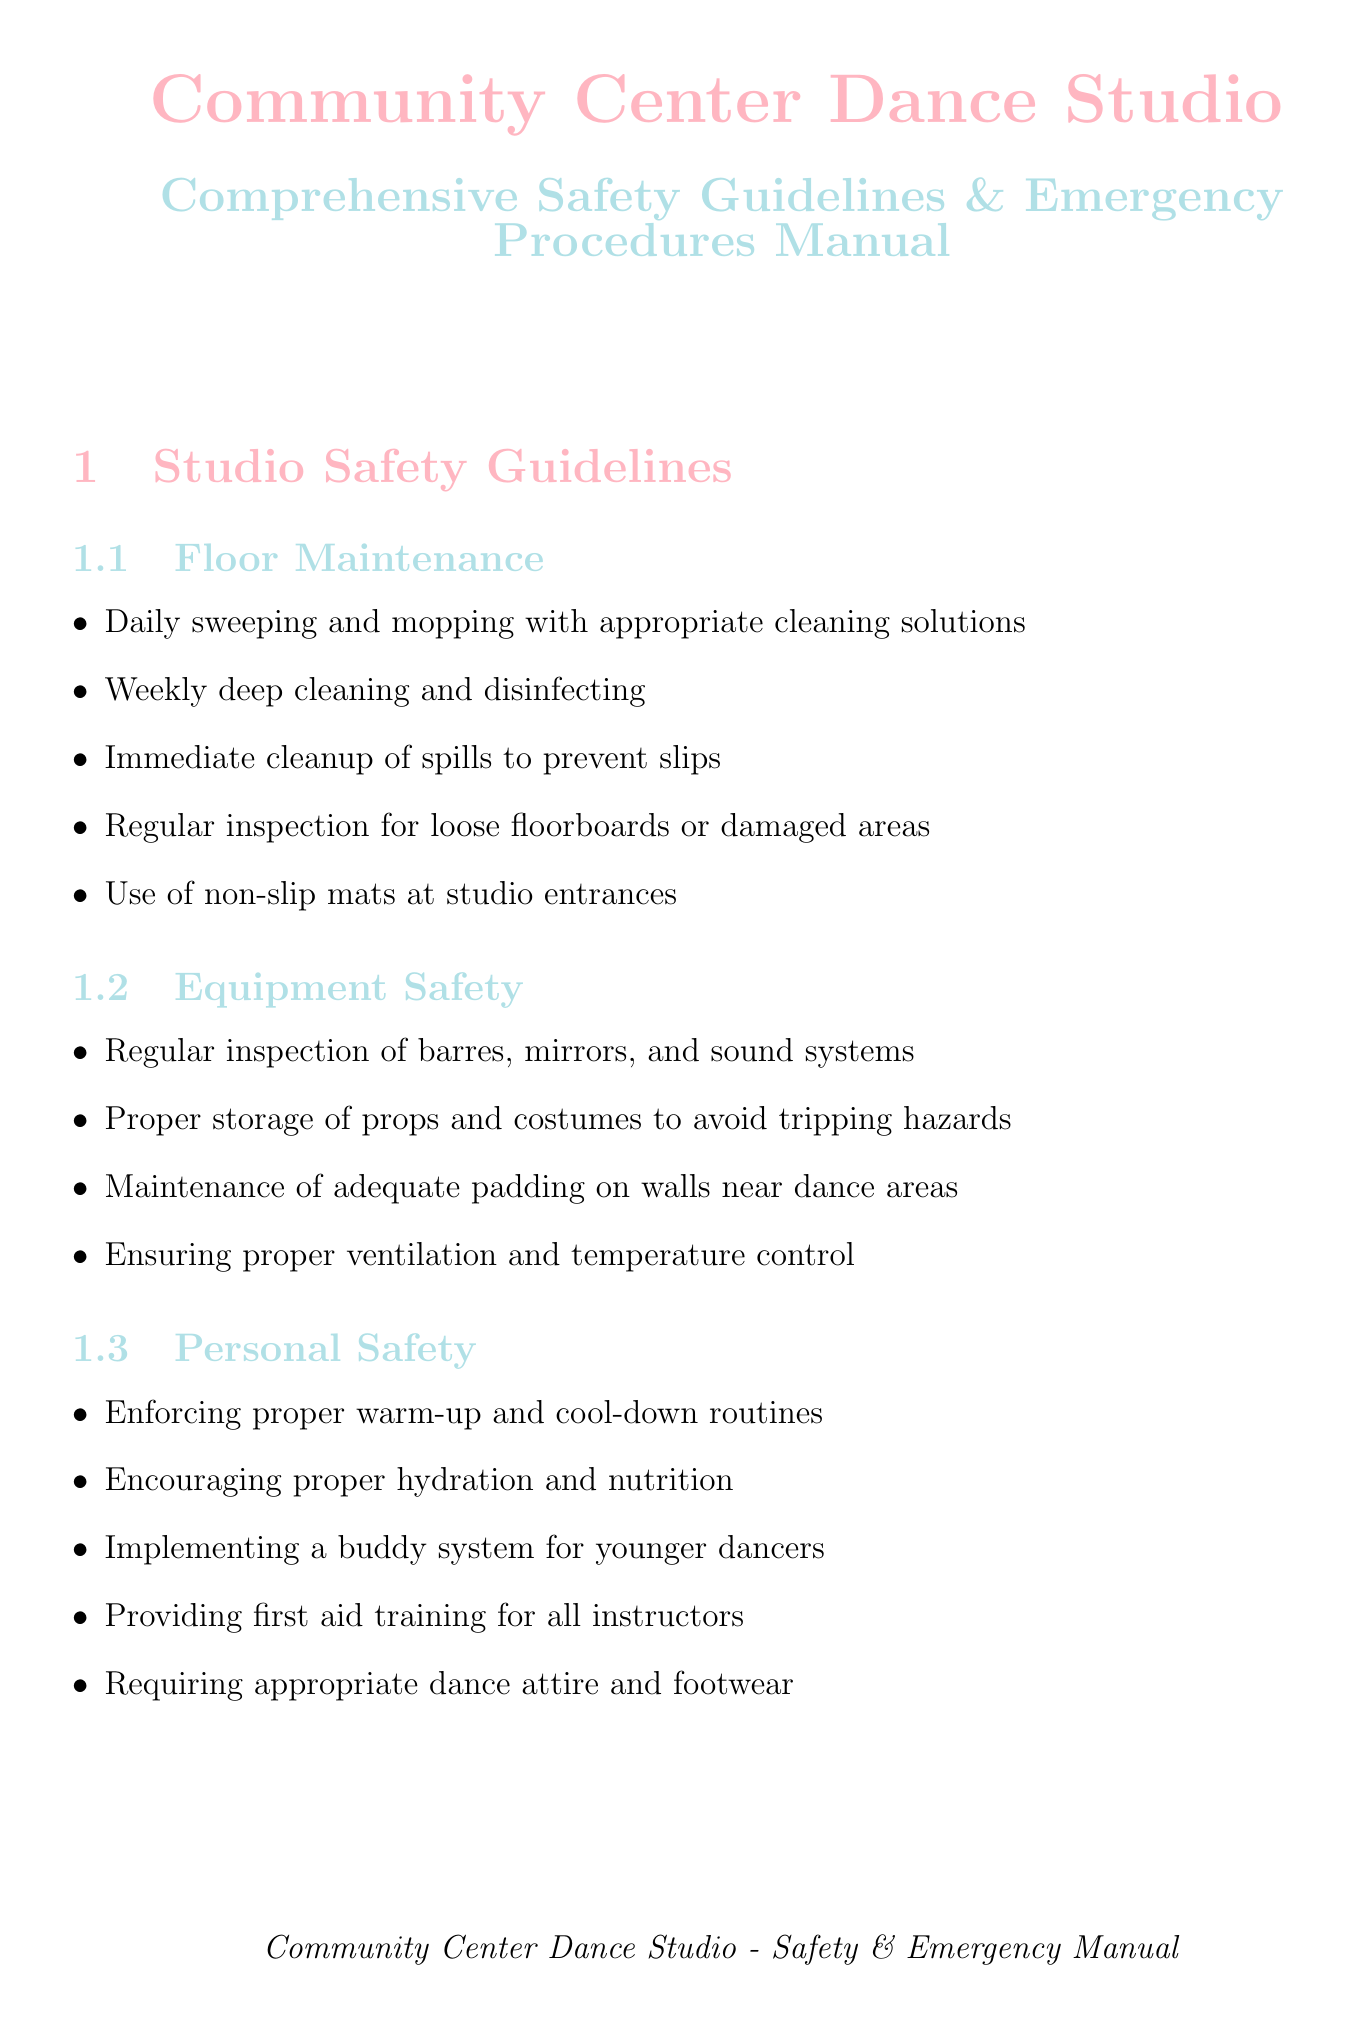What is the location of the first aid kits? The first aid kits are located behind the reception desk and in the main studio, as stated in the emergency procedures section.
Answer: behind reception desk and in main studio Who is the head dance instructor? The head dance instructor is Sarah Johnson, mentioned in the contact information section.
Answer: Sarah Johnson What should be done for immediate spills? The guideline states that spills should be immediately cleaned up to prevent slips, as part of floor maintenance.
Answer: Immediate cleanup of spills to prevent slips Where is the designated shelter area during severe weather? The designated shelter area during severe weather is the internal hallway away from windows, according to the emergency procedures.
Answer: internal hallway away from windows What safety measure is suggested for younger dancers? The document mentions implementing a buddy system for younger dancers under personal safety guidelines.
Answer: buddy system How often should fire drills practice occur? The document states monthly fire drill practice during classes as part of fire safety.
Answer: Monthly What is the designated meeting point for fire emergencies? The designated meeting point for fire emergencies is the parking lot of Johnson's Grocery Store across the street, as outlined in fire safety.
Answer: parking lot of Johnson's Grocery Store What should instructors have with regard to child protection? The guideline specifies that all instructors should have current background checks under child protection.
Answer: current background checks What should be conducted with full safety protocols in place? The document states that dress rehearsals should be conducted with full safety protocols in place, related to holiday performance preparation.
Answer: dress rehearsals 